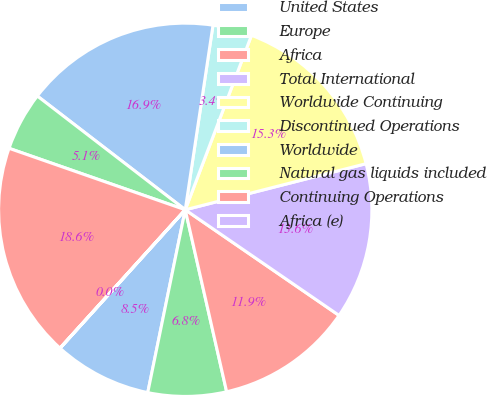Convert chart. <chart><loc_0><loc_0><loc_500><loc_500><pie_chart><fcel>United States<fcel>Europe<fcel>Africa<fcel>Total International<fcel>Worldwide Continuing<fcel>Discontinued Operations<fcel>Worldwide<fcel>Natural gas liquids included<fcel>Continuing Operations<fcel>Africa (e)<nl><fcel>8.48%<fcel>6.78%<fcel>11.86%<fcel>13.55%<fcel>15.25%<fcel>3.4%<fcel>16.94%<fcel>5.09%<fcel>18.63%<fcel>0.01%<nl></chart> 